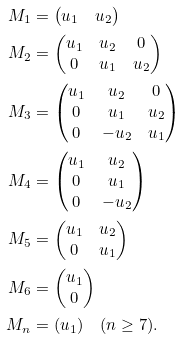Convert formula to latex. <formula><loc_0><loc_0><loc_500><loc_500>M _ { 1 } & = \begin{pmatrix} u _ { 1 } & u _ { 2 } \end{pmatrix} \\ M _ { 2 } & = \begin{pmatrix} u _ { 1 } & u _ { 2 } & 0 \\ 0 & u _ { 1 } & u _ { 2 } \end{pmatrix} \\ M _ { 3 } & = \begin{pmatrix} u _ { 1 } & u _ { 2 } & 0 \\ 0 & u _ { 1 } & u _ { 2 } \\ 0 & - u _ { 2 } & u _ { 1 } \end{pmatrix} \\ M _ { 4 } & = \begin{pmatrix} u _ { 1 } & u _ { 2 } \\ 0 & u _ { 1 } \\ 0 & - u _ { 2 } \end{pmatrix} \\ M _ { 5 } & = \begin{pmatrix} u _ { 1 } & u _ { 2 } \\ 0 & u _ { 1 } \end{pmatrix} \\ M _ { 6 } & = \begin{pmatrix} u _ { 1 } \\ 0 \end{pmatrix} \\ M _ { n } & = ( u _ { 1 } ) \quad ( n \geq 7 ) .</formula> 